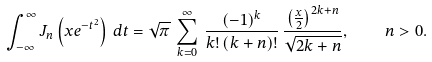Convert formula to latex. <formula><loc_0><loc_0><loc_500><loc_500>\int _ { - \infty } ^ { \infty } J _ { n } \left ( x e ^ { - t ^ { 2 } } \right ) \, d t = \sqrt { \pi } \, \sum _ { k = 0 } ^ { \infty } \, \frac { ( - 1 ) ^ { k } } { k ! \, ( k + n ) ! } \, \frac { \left ( \frac { x } { 2 } \right ) ^ { 2 k + n } } { \sqrt { 2 k + n } } , \quad n > 0 .</formula> 